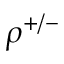<formula> <loc_0><loc_0><loc_500><loc_500>\rho ^ { + / - }</formula> 